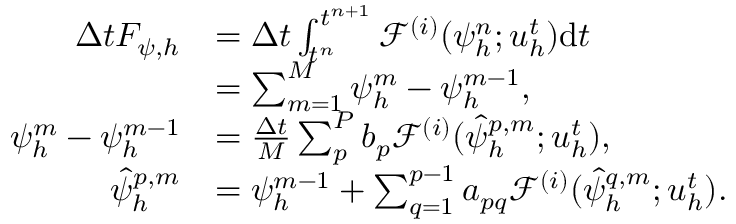<formula> <loc_0><loc_0><loc_500><loc_500>\begin{array} { r l } { \Delta t F _ { \psi , h } } & { = \Delta t \int _ { t ^ { n } } ^ { t ^ { n + 1 } } \mathcal { F } ^ { ( i ) } ( \psi _ { h } ^ { n } ; u _ { h } ^ { t } ) d t } \\ & { = \sum _ { m = 1 } ^ { M } \psi _ { h } ^ { m } - \psi _ { h } ^ { m - 1 } , } \\ { \psi _ { h } ^ { m } - \psi _ { h } ^ { m - 1 } } & { = \frac { \Delta t } { M } \sum _ { p } ^ { P } b _ { p } \mathcal { F } ^ { ( i ) } ( \hat { \psi } _ { h } ^ { p , m } ; u _ { h } ^ { t } ) , } \\ { \hat { \psi } _ { h } ^ { p , m } } & { = \psi _ { h } ^ { m - 1 } + \sum _ { q = 1 } ^ { p - 1 } a _ { p q } \mathcal { F } ^ { ( i ) } ( \hat { \psi } _ { h } ^ { q , m } ; u _ { h } ^ { t } ) . } \end{array}</formula> 